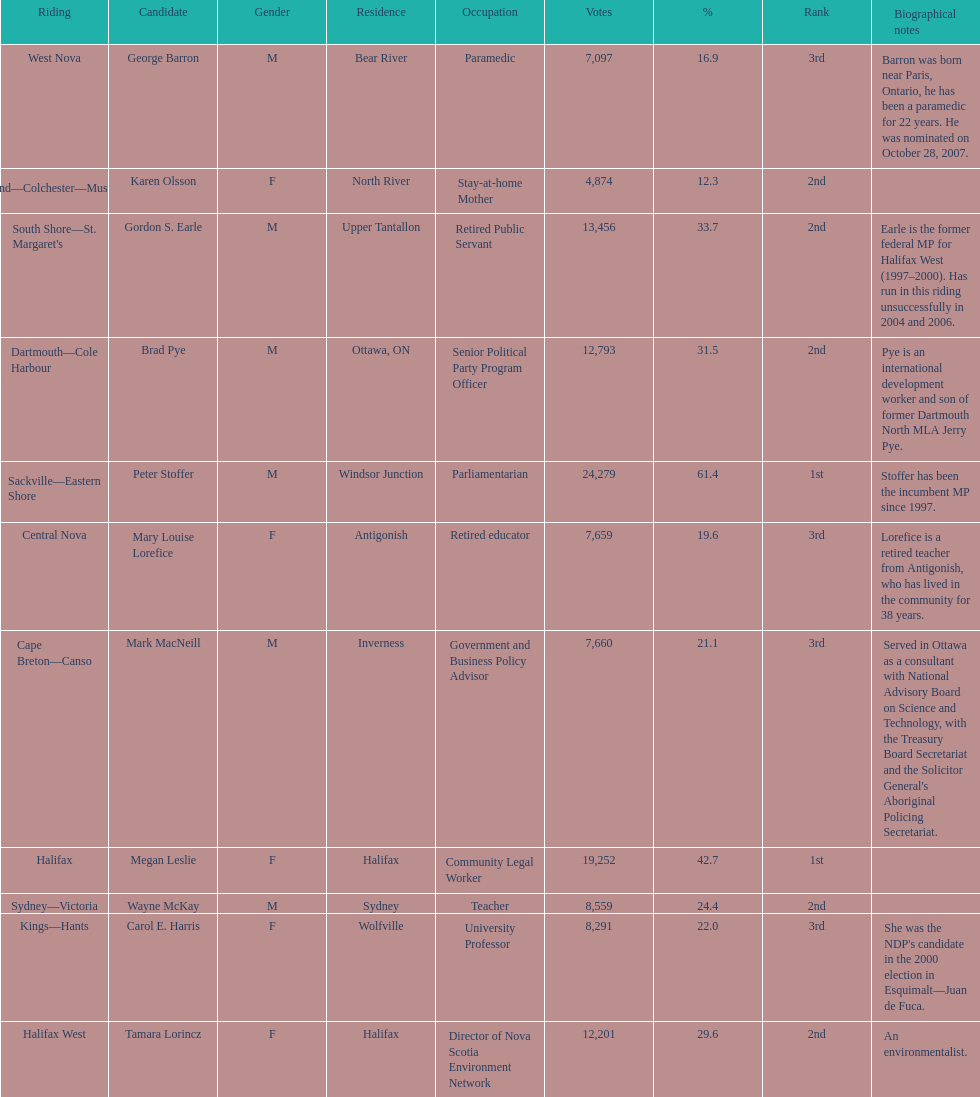How many candidates were from halifax? 2. 